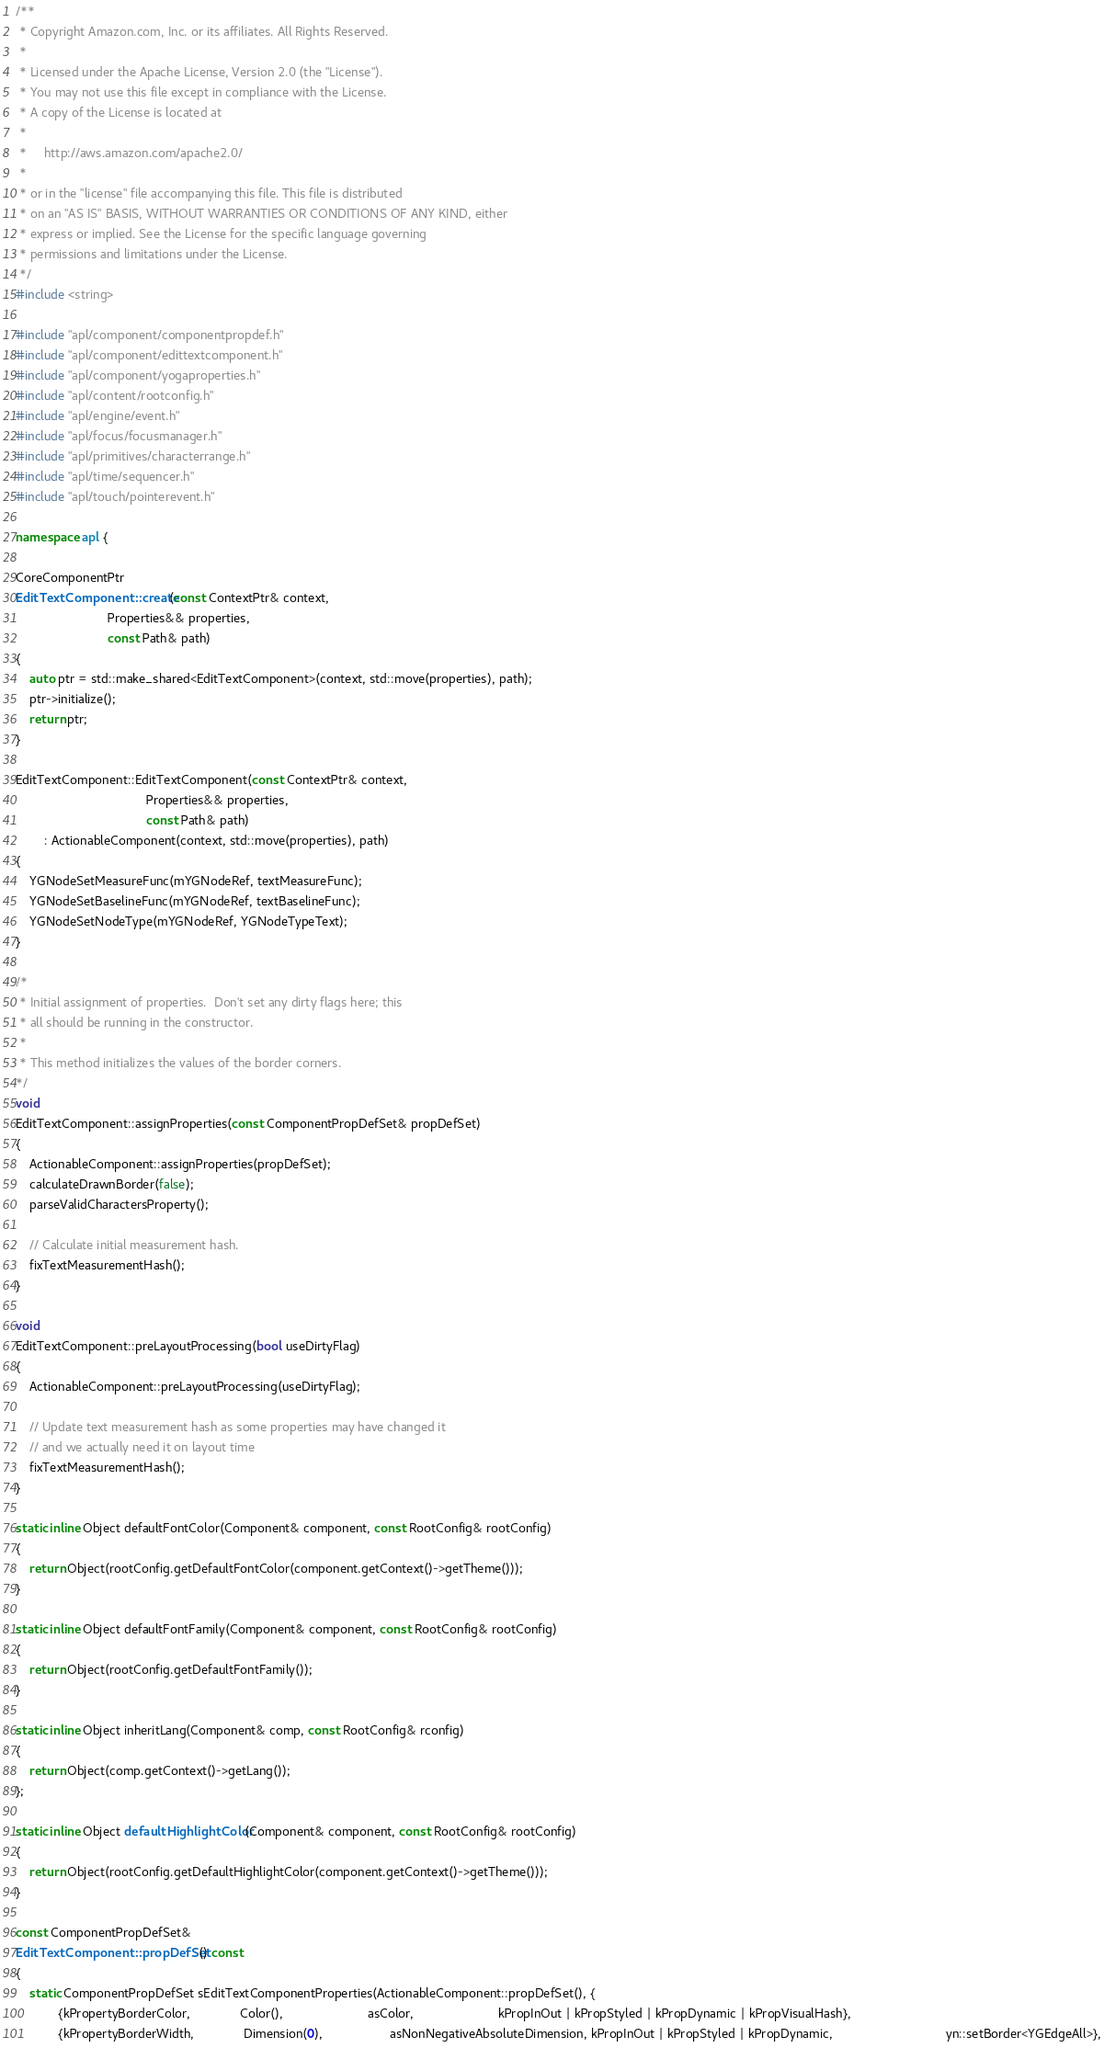<code> <loc_0><loc_0><loc_500><loc_500><_C++_>/**
 * Copyright Amazon.com, Inc. or its affiliates. All Rights Reserved.
 *
 * Licensed under the Apache License, Version 2.0 (the "License").
 * You may not use this file except in compliance with the License.
 * A copy of the License is located at
 *
 *     http://aws.amazon.com/apache2.0/
 *
 * or in the "license" file accompanying this file. This file is distributed
 * on an "AS IS" BASIS, WITHOUT WARRANTIES OR CONDITIONS OF ANY KIND, either
 * express or implied. See the License for the specific language governing
 * permissions and limitations under the License.
 */
#include <string>

#include "apl/component/componentpropdef.h"
#include "apl/component/edittextcomponent.h"
#include "apl/component/yogaproperties.h"
#include "apl/content/rootconfig.h"
#include "apl/engine/event.h"
#include "apl/focus/focusmanager.h"
#include "apl/primitives/characterrange.h"
#include "apl/time/sequencer.h"
#include "apl/touch/pointerevent.h"

namespace apl {

CoreComponentPtr
EditTextComponent::create(const ContextPtr& context,
                          Properties&& properties,
                          const Path& path)
{
    auto ptr = std::make_shared<EditTextComponent>(context, std::move(properties), path);
    ptr->initialize();
    return ptr;
}

EditTextComponent::EditTextComponent(const ContextPtr& context,
                                     Properties&& properties,
                                     const Path& path)
        : ActionableComponent(context, std::move(properties), path)
{
    YGNodeSetMeasureFunc(mYGNodeRef, textMeasureFunc);
    YGNodeSetBaselineFunc(mYGNodeRef, textBaselineFunc);
    YGNodeSetNodeType(mYGNodeRef, YGNodeTypeText);
}

/*
 * Initial assignment of properties.  Don't set any dirty flags here; this
 * all should be running in the constructor.
 *
 * This method initializes the values of the border corners.
*/
void
EditTextComponent::assignProperties(const ComponentPropDefSet& propDefSet)
{
    ActionableComponent::assignProperties(propDefSet);
    calculateDrawnBorder(false);
    parseValidCharactersProperty();

    // Calculate initial measurement hash.
    fixTextMeasurementHash();
}

void
EditTextComponent::preLayoutProcessing(bool useDirtyFlag)
{
    ActionableComponent::preLayoutProcessing(useDirtyFlag);

    // Update text measurement hash as some properties may have changed it
    // and we actually need it on layout time
    fixTextMeasurementHash();
}

static inline Object defaultFontColor(Component& component, const RootConfig& rootConfig)
{
    return Object(rootConfig.getDefaultFontColor(component.getContext()->getTheme()));
}

static inline Object defaultFontFamily(Component& component, const RootConfig& rootConfig)
{
    return Object(rootConfig.getDefaultFontFamily());
}

static inline Object inheritLang(Component& comp, const RootConfig& rconfig)
{
    return Object(comp.getContext()->getLang());
};

static inline Object defaultHighlightColor(Component& component, const RootConfig& rootConfig)
{
    return Object(rootConfig.getDefaultHighlightColor(component.getContext()->getTheme()));
}

const ComponentPropDefSet&
EditTextComponent::propDefSet() const
{
    static ComponentPropDefSet sEditTextComponentProperties(ActionableComponent::propDefSet(), {
            {kPropertyBorderColor,              Color(),                        asColor,                        kPropInOut | kPropStyled | kPropDynamic | kPropVisualHash},
            {kPropertyBorderWidth,              Dimension(0),                   asNonNegativeAbsoluteDimension, kPropInOut | kPropStyled | kPropDynamic,                                yn::setBorder<YGEdgeAll>},</code> 